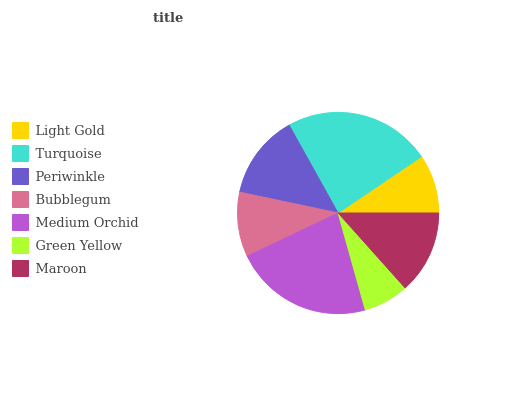Is Green Yellow the minimum?
Answer yes or no. Yes. Is Turquoise the maximum?
Answer yes or no. Yes. Is Periwinkle the minimum?
Answer yes or no. No. Is Periwinkle the maximum?
Answer yes or no. No. Is Turquoise greater than Periwinkle?
Answer yes or no. Yes. Is Periwinkle less than Turquoise?
Answer yes or no. Yes. Is Periwinkle greater than Turquoise?
Answer yes or no. No. Is Turquoise less than Periwinkle?
Answer yes or no. No. Is Maroon the high median?
Answer yes or no. Yes. Is Maroon the low median?
Answer yes or no. Yes. Is Green Yellow the high median?
Answer yes or no. No. Is Medium Orchid the low median?
Answer yes or no. No. 